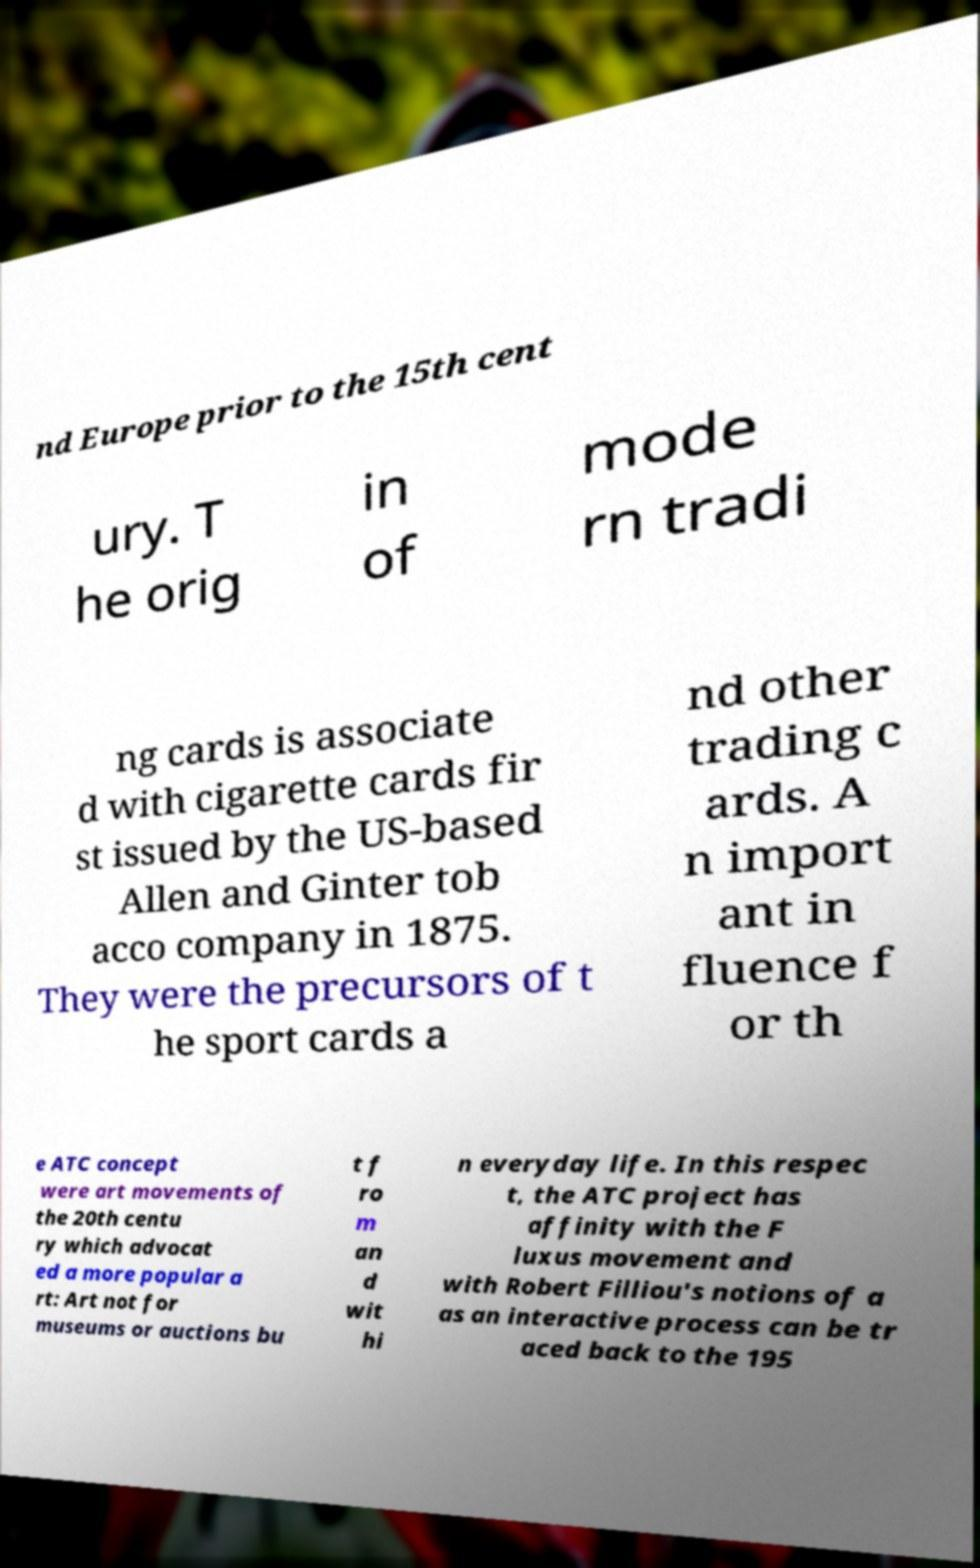Could you assist in decoding the text presented in this image and type it out clearly? nd Europe prior to the 15th cent ury. T he orig in of mode rn tradi ng cards is associate d with cigarette cards fir st issued by the US-based Allen and Ginter tob acco company in 1875. They were the precursors of t he sport cards a nd other trading c ards. A n import ant in fluence f or th e ATC concept were art movements of the 20th centu ry which advocat ed a more popular a rt: Art not for museums or auctions bu t f ro m an d wit hi n everyday life. In this respec t, the ATC project has affinity with the F luxus movement and with Robert Filliou's notions of a as an interactive process can be tr aced back to the 195 